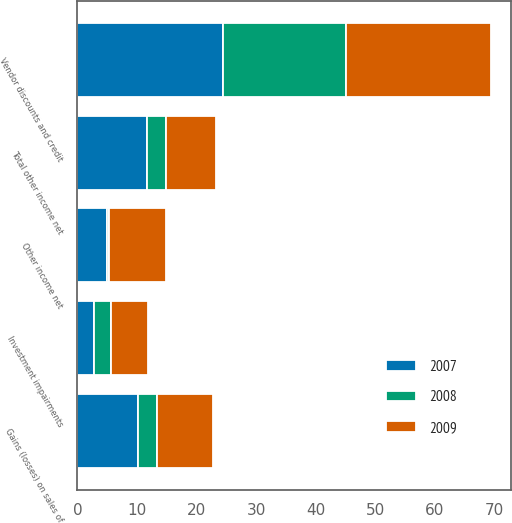Convert chart to OTSL. <chart><loc_0><loc_0><loc_500><loc_500><stacked_bar_chart><ecel><fcel>Gains (losses) on sales of<fcel>Vendor discounts and credit<fcel>Investment impairments<fcel>Other income net<fcel>Total other income net<nl><fcel>2007<fcel>10.2<fcel>24.4<fcel>2.7<fcel>4.9<fcel>11.7<nl><fcel>2008<fcel>3.1<fcel>20.7<fcel>2.9<fcel>0.4<fcel>3.1<nl><fcel>2009<fcel>9.4<fcel>24.3<fcel>6.2<fcel>9.5<fcel>8.5<nl></chart> 